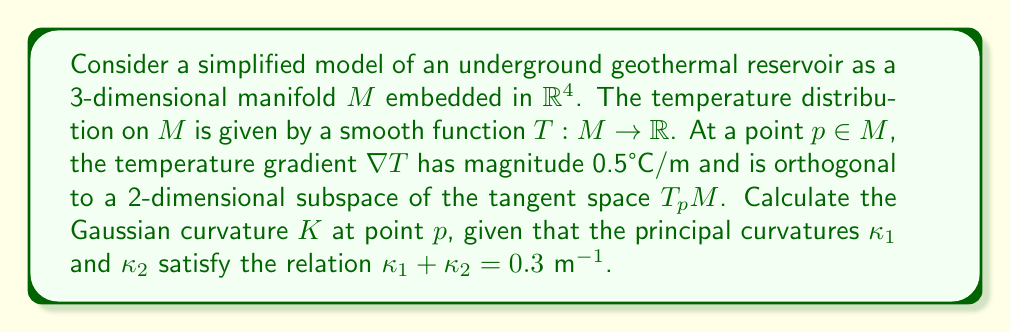Solve this math problem. To solve this problem, we'll follow these steps:

1) First, recall that the Gaussian curvature $K$ is the product of the principal curvatures:

   $$K = \kappa_1 \kappa_2$$

2) We're given that $\kappa_1 + \kappa_2 = 0.3 \text{ m}^{-1}$. Let's call this equation (1).

3) We need another equation relating $\kappa_1$ and $\kappa_2$. We can use the fact that the temperature gradient is orthogonal to a 2-dimensional subspace of $T_pM$.

4) In differential geometry, the shape operator $S$ (also known as the Weingarten map) relates the temperature gradient to the principal curvatures:

   $$S(\nabla T) = -\nabla_{\nabla T} N$$

   where $N$ is the unit normal vector to $M$ at $p$.

5) Given that $\nabla T$ is orthogonal to a 2-dimensional subspace, it must be parallel to the direction of one of the principal curvatures. Without loss of generality, let's assume it's in the direction of $\kappa_1$.

6) The magnitude of $S(\nabla T)$ is then given by:

   $$\|S(\nabla T)\| = \|\kappa_1 \nabla T\| = |\kappa_1| \cdot 0.5$$

7) On the other hand, $\|-\nabla_{\nabla T} N\| = 0.5$, as this is the rate of change of the normal vector in the direction of the temperature gradient.

8) Equating these:

   $$|\kappa_1| \cdot 0.5 = 0.5$$

   $$|\kappa_1| = 1 \text{ m}^{-1}$$

9) Since we don't know the sign of $\kappa_1$, we have two possible cases:
   Case 1: $\kappa_1 = 1 \text{ m}^{-1}$
   Case 2: $\kappa_1 = -1 \text{ m}^{-1}$

10) Using equation (1) from step 2:
    Case 1: $\kappa_2 = 0.3 - 1 = -0.7 \text{ m}^{-1}$
    Case 2: $\kappa_2 = 0.3 - (-1) = 1.3 \text{ m}^{-1}$

11) The Gaussian curvature is the same in both cases:

    $$K = \kappa_1 \kappa_2 = 1 \cdot (-0.7) = -1 \cdot 1.3 = -0.7 \text{ m}^{-2}$$

Therefore, the Gaussian curvature $K$ at point $p$ is $-0.7 \text{ m}^{-2}$.
Answer: $K = -0.7 \text{ m}^{-2}$ 